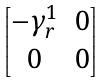<formula> <loc_0><loc_0><loc_500><loc_500>\begin{bmatrix} - \gamma _ { r } ^ { 1 } & 0 \\ 0 & 0 \end{bmatrix}</formula> 